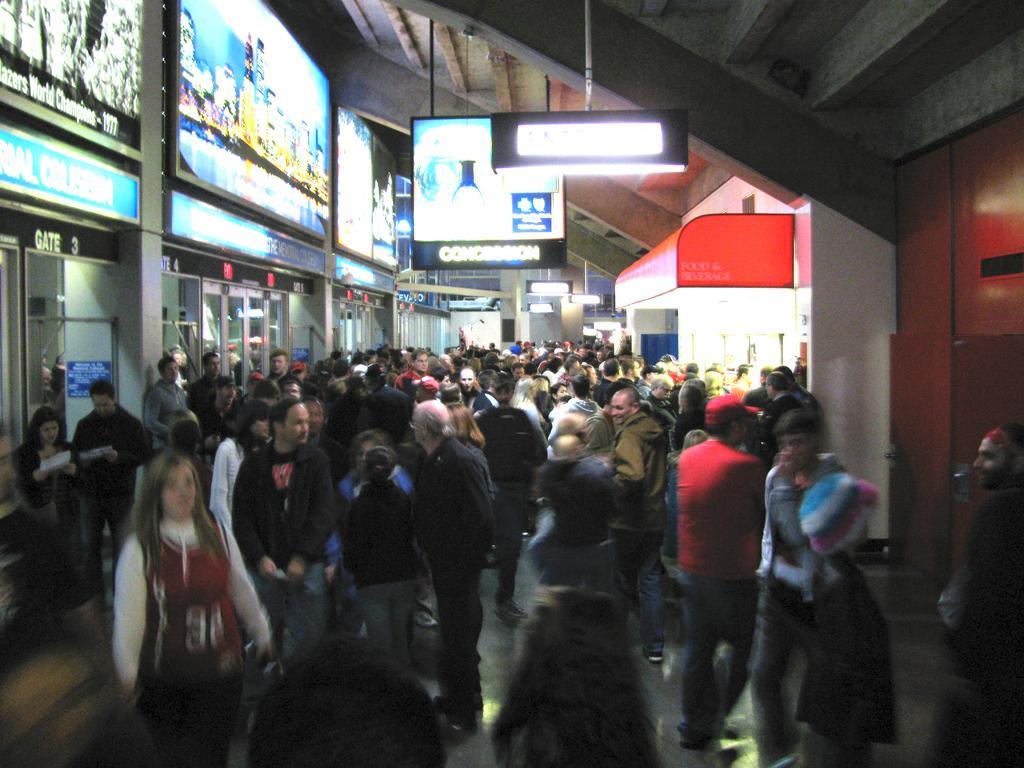Describe this image in one or two sentences. This image contains few persons walking on the floor. Few boards and lights are hanged from the roof. Behind the persons there are few shops. 